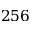Convert formula to latex. <formula><loc_0><loc_0><loc_500><loc_500>2 5 6</formula> 